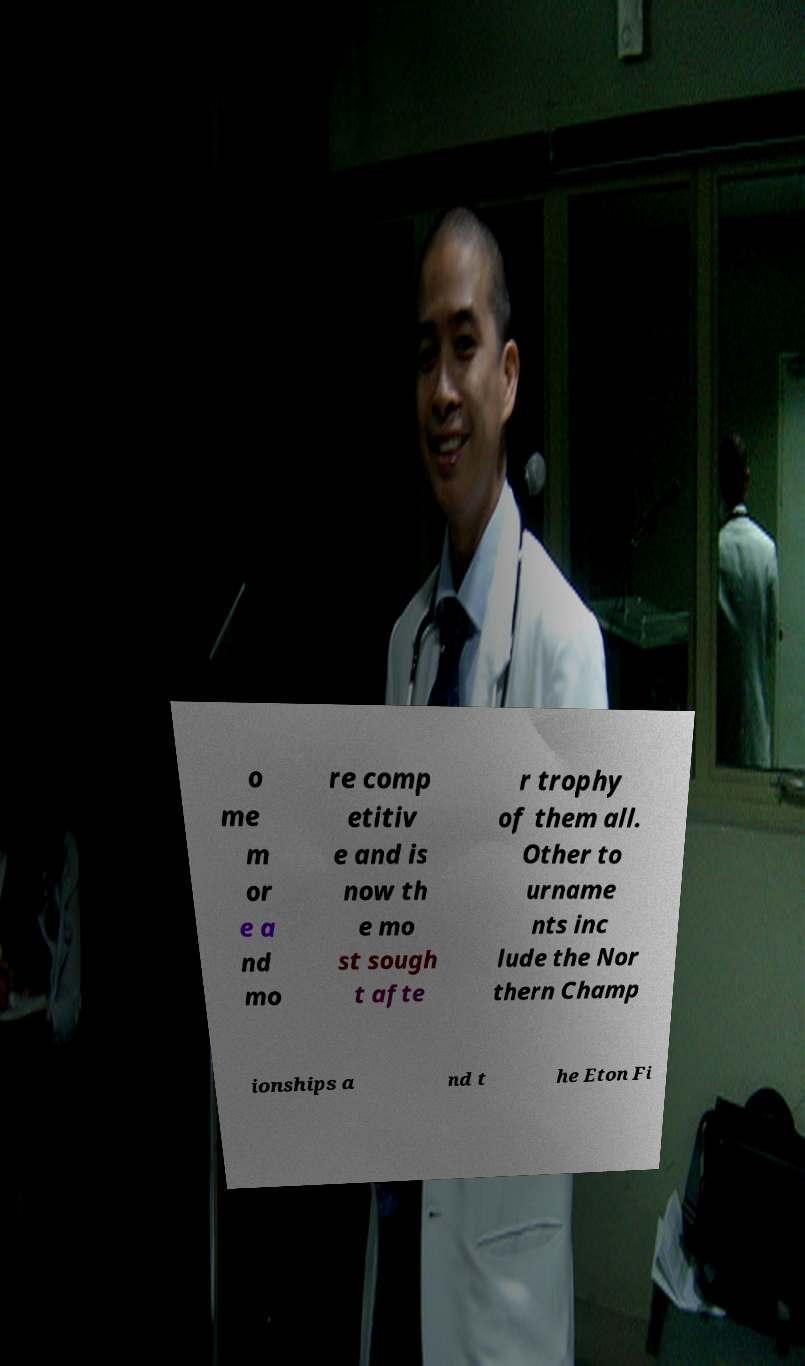Can you accurately transcribe the text from the provided image for me? o me m or e a nd mo re comp etitiv e and is now th e mo st sough t afte r trophy of them all. Other to urname nts inc lude the Nor thern Champ ionships a nd t he Eton Fi 